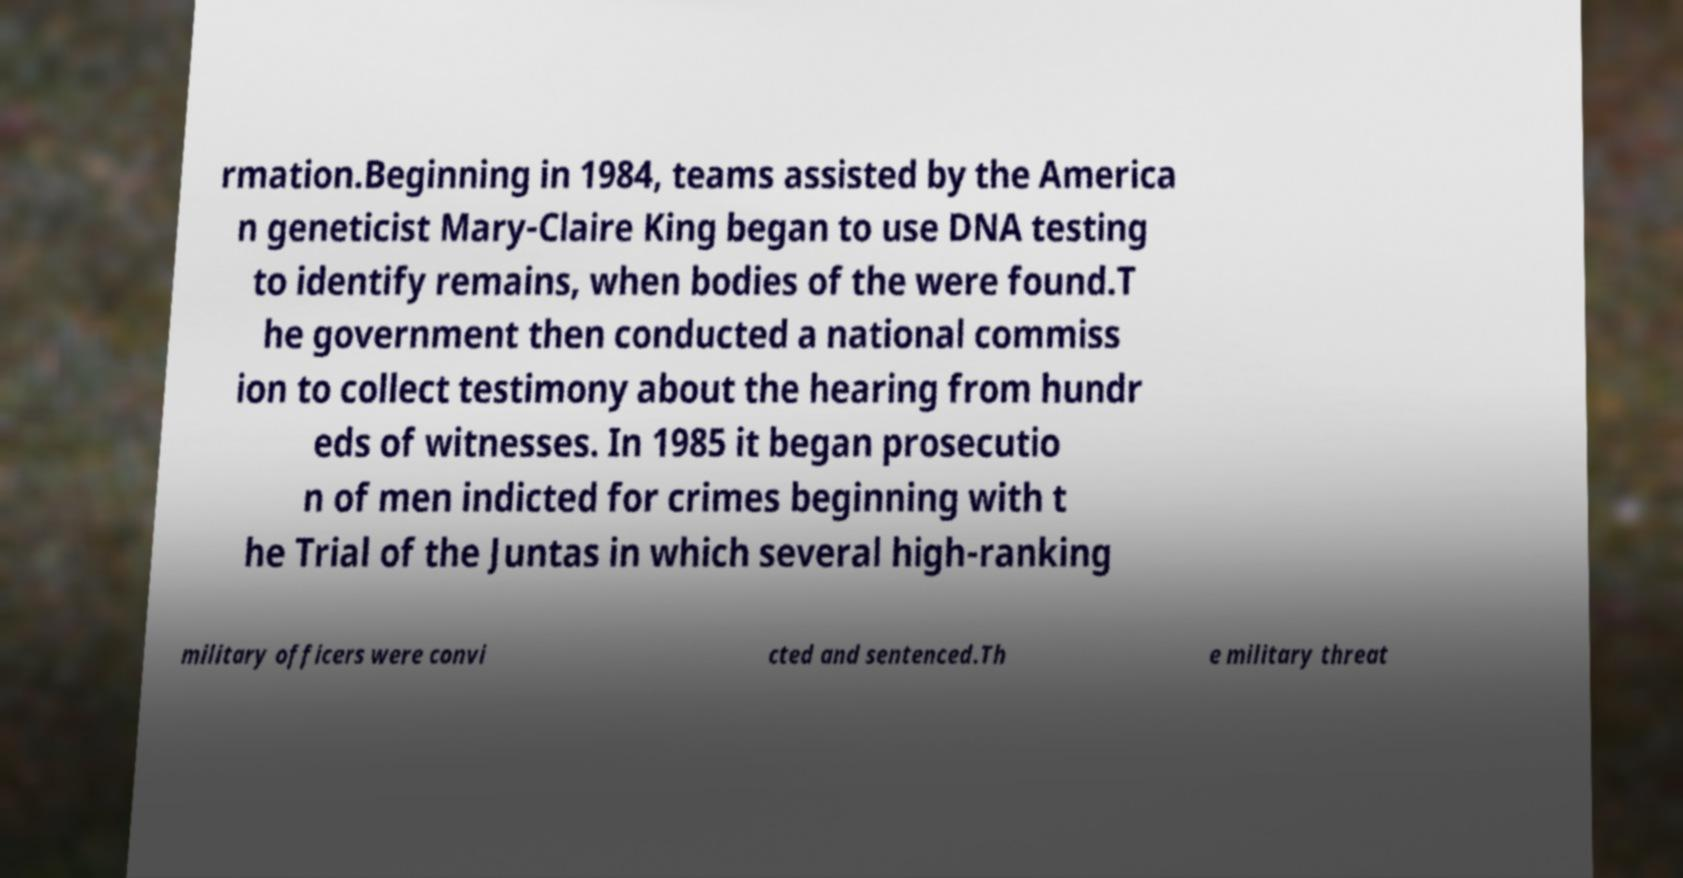There's text embedded in this image that I need extracted. Can you transcribe it verbatim? rmation.Beginning in 1984, teams assisted by the America n geneticist Mary-Claire King began to use DNA testing to identify remains, when bodies of the were found.T he government then conducted a national commiss ion to collect testimony about the hearing from hundr eds of witnesses. In 1985 it began prosecutio n of men indicted for crimes beginning with t he Trial of the Juntas in which several high-ranking military officers were convi cted and sentenced.Th e military threat 